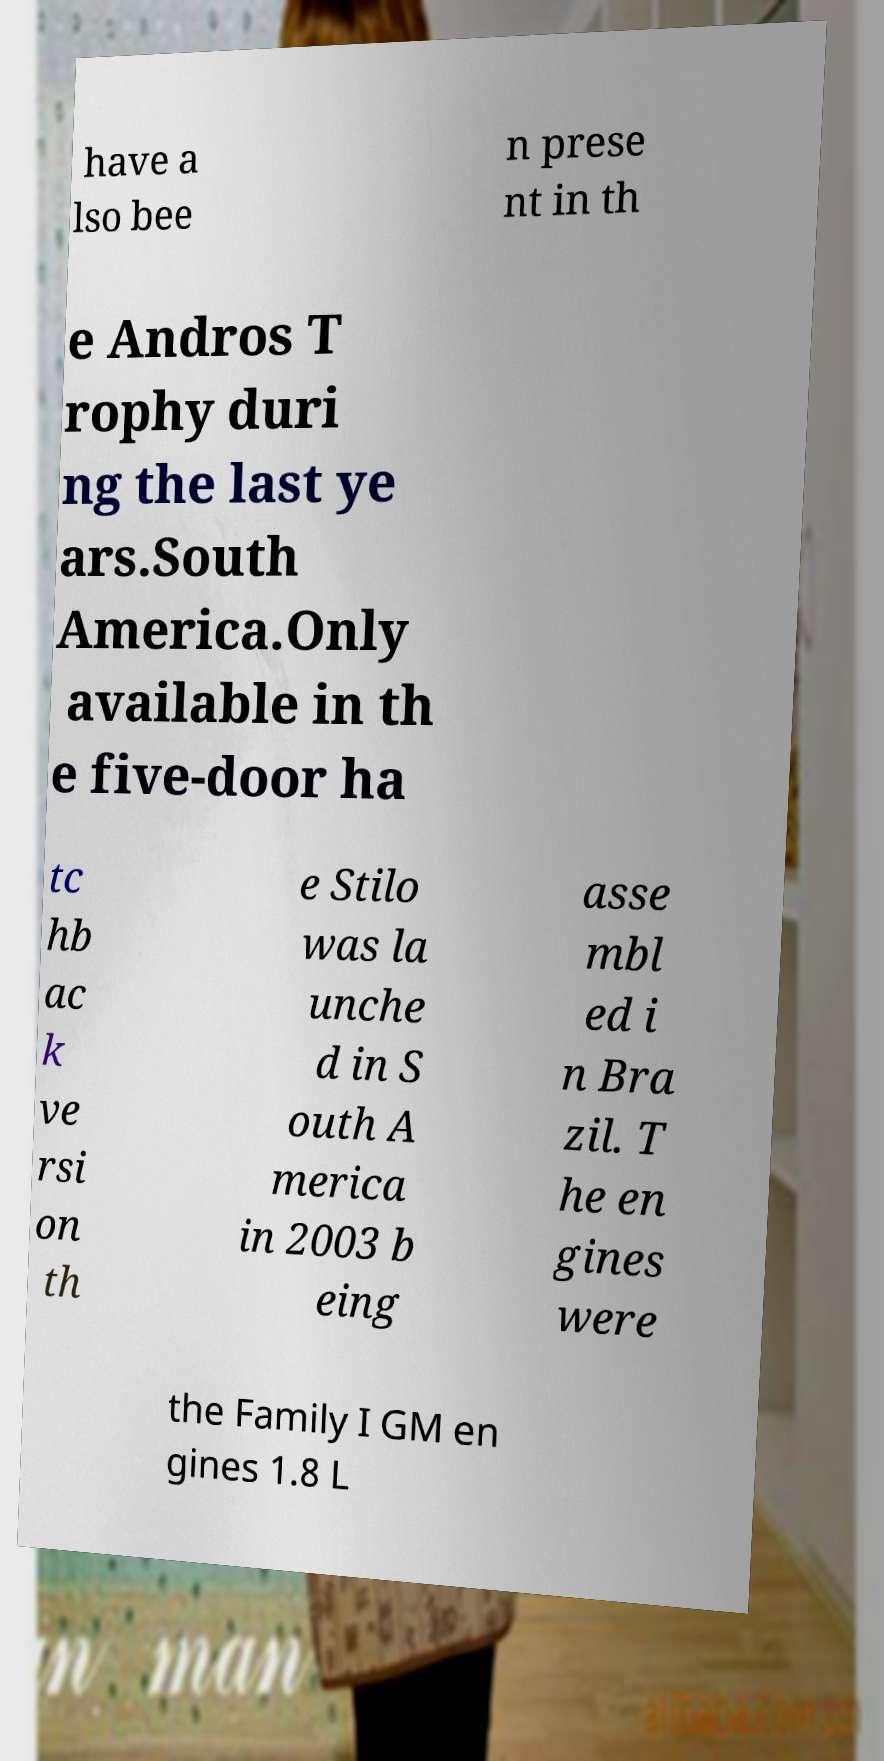There's text embedded in this image that I need extracted. Can you transcribe it verbatim? have a lso bee n prese nt in th e Andros T rophy duri ng the last ye ars.South America.Only available in th e five-door ha tc hb ac k ve rsi on th e Stilo was la unche d in S outh A merica in 2003 b eing asse mbl ed i n Bra zil. T he en gines were the Family I GM en gines 1.8 L 